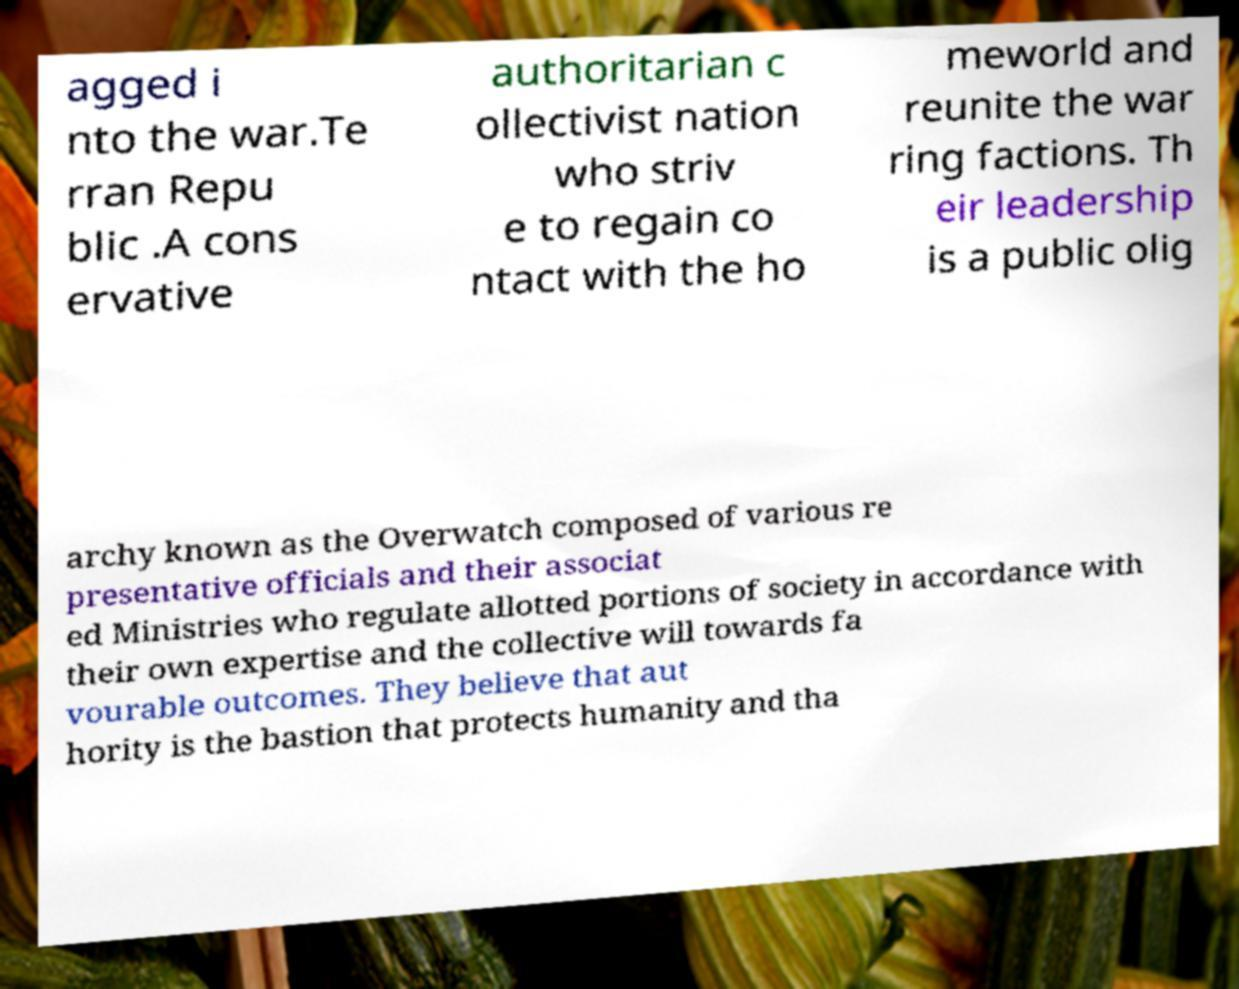Please read and relay the text visible in this image. What does it say? agged i nto the war.Te rran Repu blic .A cons ervative authoritarian c ollectivist nation who striv e to regain co ntact with the ho meworld and reunite the war ring factions. Th eir leadership is a public olig archy known as the Overwatch composed of various re presentative officials and their associat ed Ministries who regulate allotted portions of society in accordance with their own expertise and the collective will towards fa vourable outcomes. They believe that aut hority is the bastion that protects humanity and tha 